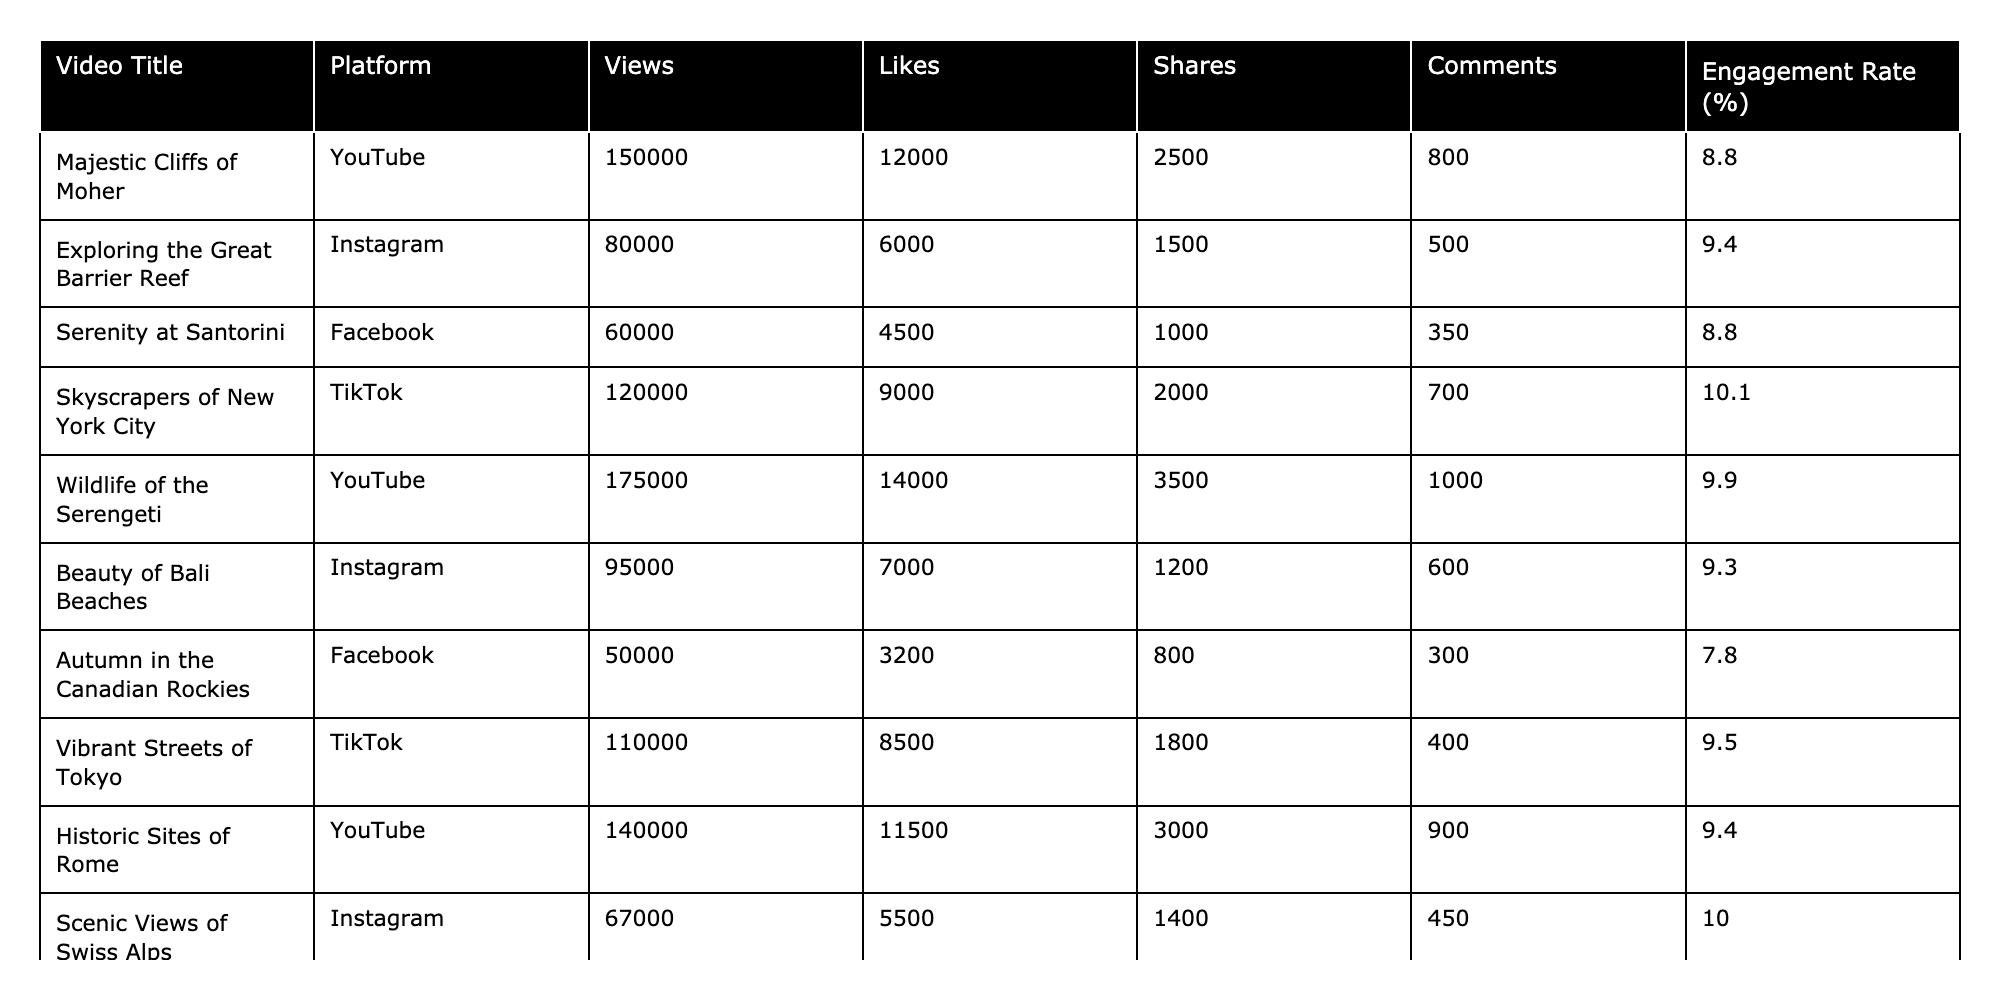What is the video with the highest number of views? By looking at the "Views" column, "Wildlife of the Serengeti" has the highest value at 175,000 views.
Answer: Wildlife of the Serengeti Which video has the lowest engagement rate? The engagement rate is lowest for "Autumn in the Canadian Rockies" at 7.8%.
Answer: Autumn in the Canadian Rockies How many total likes did the videos on Instagram receive? The total likes for Instagram videos can be calculated as (6000 + 7000 + 5500) = 18500.
Answer: 18500 What is the average engagement rate for videos on YouTube? The engagement rates for YouTube videos are 8.8%, 9.9%, and 9.4%. Their total is 27.1%, and dividing by 3 gives an average of 9.0%.
Answer: 9.0% Is the engagement rate for "Skyscrapers of New York City" higher than 10%? The engagement rate for "Skyscrapers of New York City" is 10.1%, which is indeed higher than 10%.
Answer: Yes Which platform has the most videos listed? By counting the entries for each platform, YouTube has 4 videos, which is more than any other platform.
Answer: YouTube How many shares did the video "Serenity at Santorini" receive compared to "Beauty of Bali Beaches"? "Serenity at Santorini" received 1000 shares while "Beauty of Bali Beaches" received 1200 shares, making the latter higher by 200 shares.
Answer: 200 more shares for Beauty of Bali Beaches What is the total number of comments across all videos? Adding all comments gives (800 + 500 + 350 + 700 + 1000 + 600 + 300 + 400 + 900) = 5250 total comments.
Answer: 5250 For which video do likes contribute the most to the engagement rate? To find the contribution, compare (Likes/Views) for each video; "Wildlife of the Serengeti" has the greatest likes relative to its views, contributing significantly to its 9.9% engagement rate.
Answer: Wildlife of the Serengeti Do all videos on TikTok have an engagement rate above 9%? The engagement rates for TikTok videos are 10.1% and 9.5%, both above 9%.
Answer: Yes 